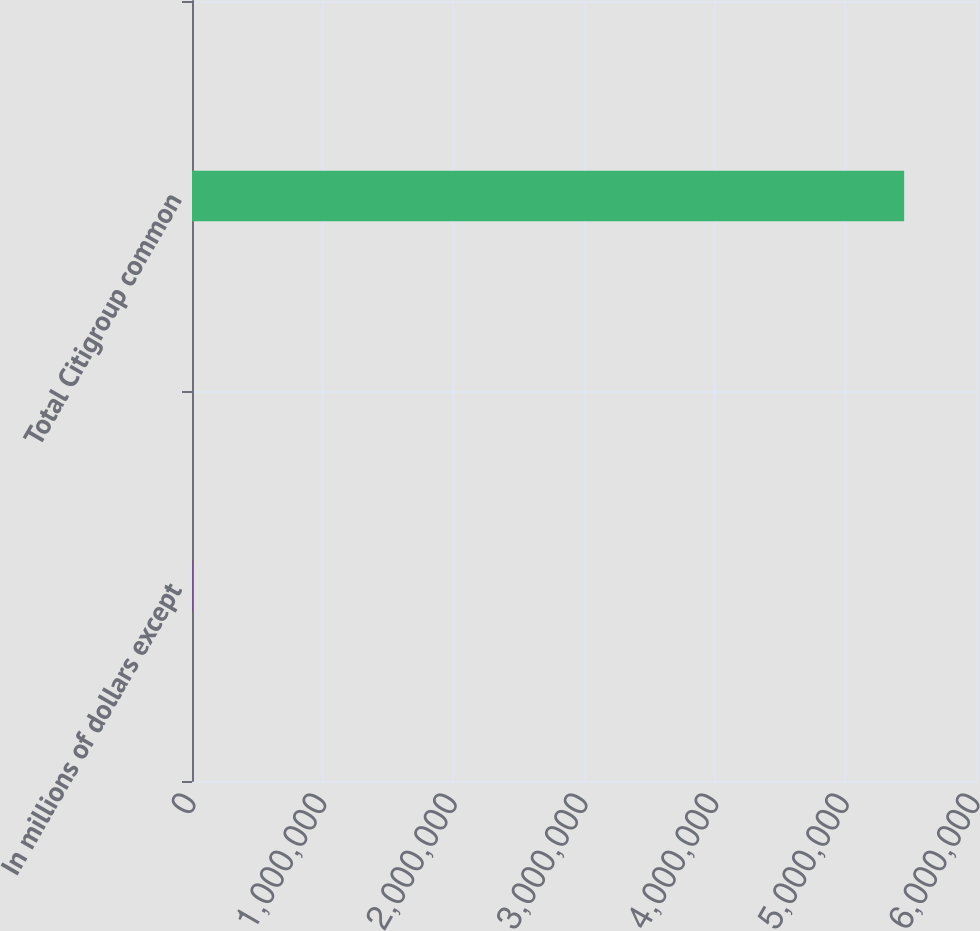Convert chart. <chart><loc_0><loc_0><loc_500><loc_500><bar_chart><fcel>In millions of dollars except<fcel>Total Citigroup common<nl><fcel>2008<fcel>5.45007e+06<nl></chart> 